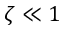<formula> <loc_0><loc_0><loc_500><loc_500>\zeta \ll 1</formula> 